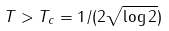Convert formula to latex. <formula><loc_0><loc_0><loc_500><loc_500>T > T _ { c } = 1 / ( 2 \sqrt { \log 2 } )</formula> 